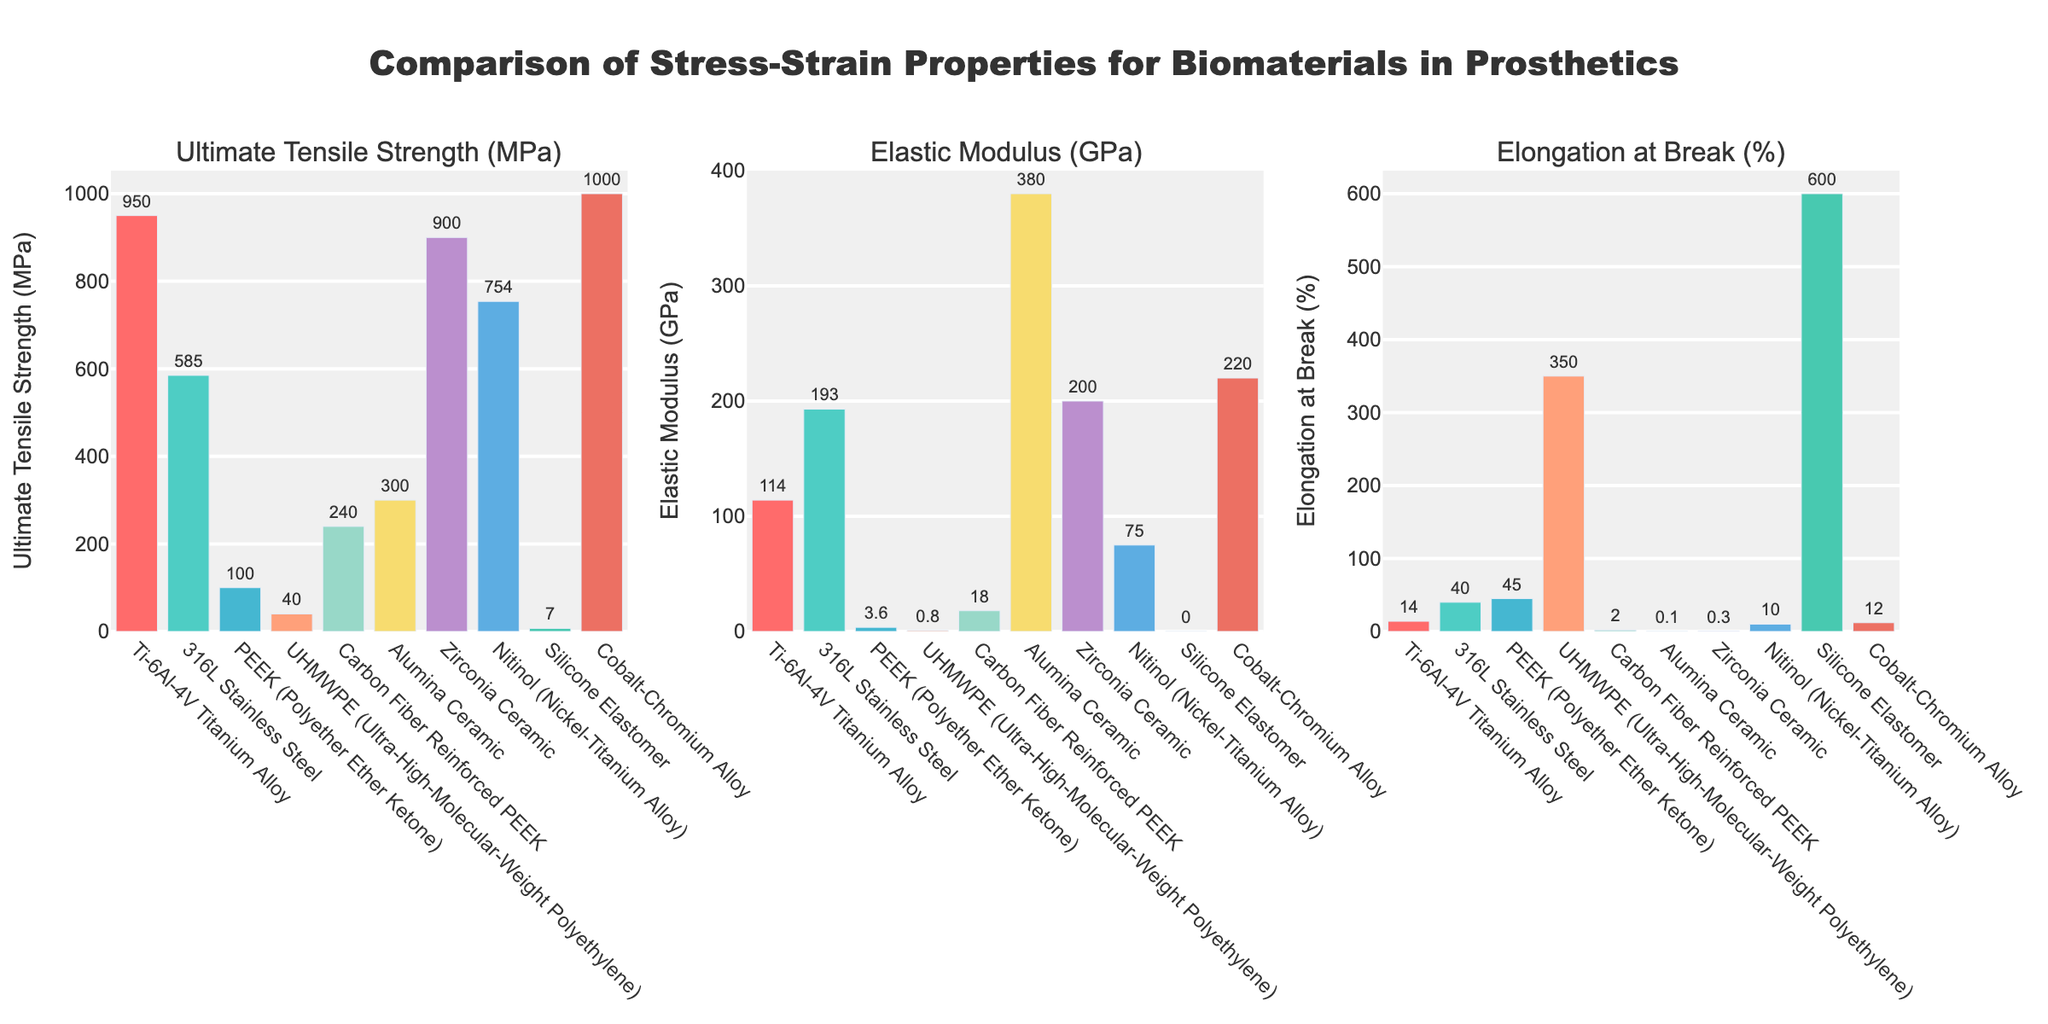What material has the highest ultimate tensile strength? By visually examining the heights of the bars in the "Ultimate Tensile Strength (MPa)" subplot, we notice that the Cobalt-Chromium Alloy bar is the tallest, which indicates it has the highest value.
Answer: Cobalt-Chromium Alloy Which material has the lowest elongation at break? In the "Elongation at Break (%)" subplot, the bar representing Alumina Ceramic is the shortest among all materials, indicating the lowest elongation at break percentage.
Answer: Alumina Ceramic How much greater is the elastic modulus of Alumina Ceramic compared to UHMWPE? From the "Elastic Modulus (GPa)" subplot, we see that Alumina Ceramic has a value of 380 GPa and UHMWPE has 0.8 GPa. Subtracting the two values gives 380 - 0.8 = 379.2 GPa.
Answer: 379.2 GPa Which two materials display the most significant difference in ultimate tensile strength? In the "Ultimate Tensile Strength (MPa)" subplot, the Cobalt-Chromium Alloy has the highest value (1000 MPa) and Silicone Elastomer has the lowest (7 MPa). The difference is 1000 - 7 = 993 MPa.
Answer: Cobalt-Chromium Alloy and Silicone Elastomer Rank the materials from highest to lowest based on their elongation at break. By visually comparing the heights of the bars in the "Elongation at Break (%)" subplot, we can rank materials as follows: Silicone Elastomer (highest), UHMWPE, PEEK, 316L Stainless Steel, Ti-6Al-4V Titanium Alloy, Nitinol, Cobalt-Chromium Alloy, Carbon Fiber Reinforced PEEK, Zirconia Ceramic, Alumina Ceramic (lowest).
Answer: Silicone Elastomer, UHMWPE, PEEK, 316L Stainless Steel, Ti-6Al-4V Titanium Alloy, Nitinol, Cobalt-Chromium Alloy, Carbon Fiber Reinforced PEEK, Zirconia Ceramic, Alumina Ceramic Which material shows an unusual combination of a high ultimate tensile strength and a low elongation at break? By examining the "Ultimate Tensile Strength (MPa)" and "Elongation at Break (%)" subplots together, we note that Zirconia Ceramic has one of the highest tensile strength values (900 MPa) but a very low elongation at break (0.3%).
Answer: Zirconia Ceramic What is the average ultimate tensile strength of the metal alloys in the data set? Metal alloys in the dataset are Ti-6Al-4V Titanium Alloy, 316L Stainless Steel, Nitinol, and Cobalt-Chromium Alloy. Their ultimate tensile strengths are 950 MPa, 585 MPa, 754 MPa, and 1000 MPa respectively. The average is (950 + 585 + 754 + 1000) / 4 = 822.25 MPa.
Answer: 822.25 MPa What is the difference in elongation at break percentage between PEEK and Carbon Fiber Reinforced PEEK? In the "Elongation at Break (%)" subplot, PEEK has a value of 45% and Carbon Fiber Reinforced PEEK has 2%. The difference is 45 - 2 = 43%.
Answer: 43% Which material has the second highest elastic modulus? By analyzing the "Elastic Modulus (GPa)" subplot, we see that Zirconia Ceramic has the highest value followed by Cobalt-Chromium Alloy. Therefore, Cobalt-Chromium Alloy has the second highest elastic modulus.
Answer: Cobalt-Chromium Alloy 